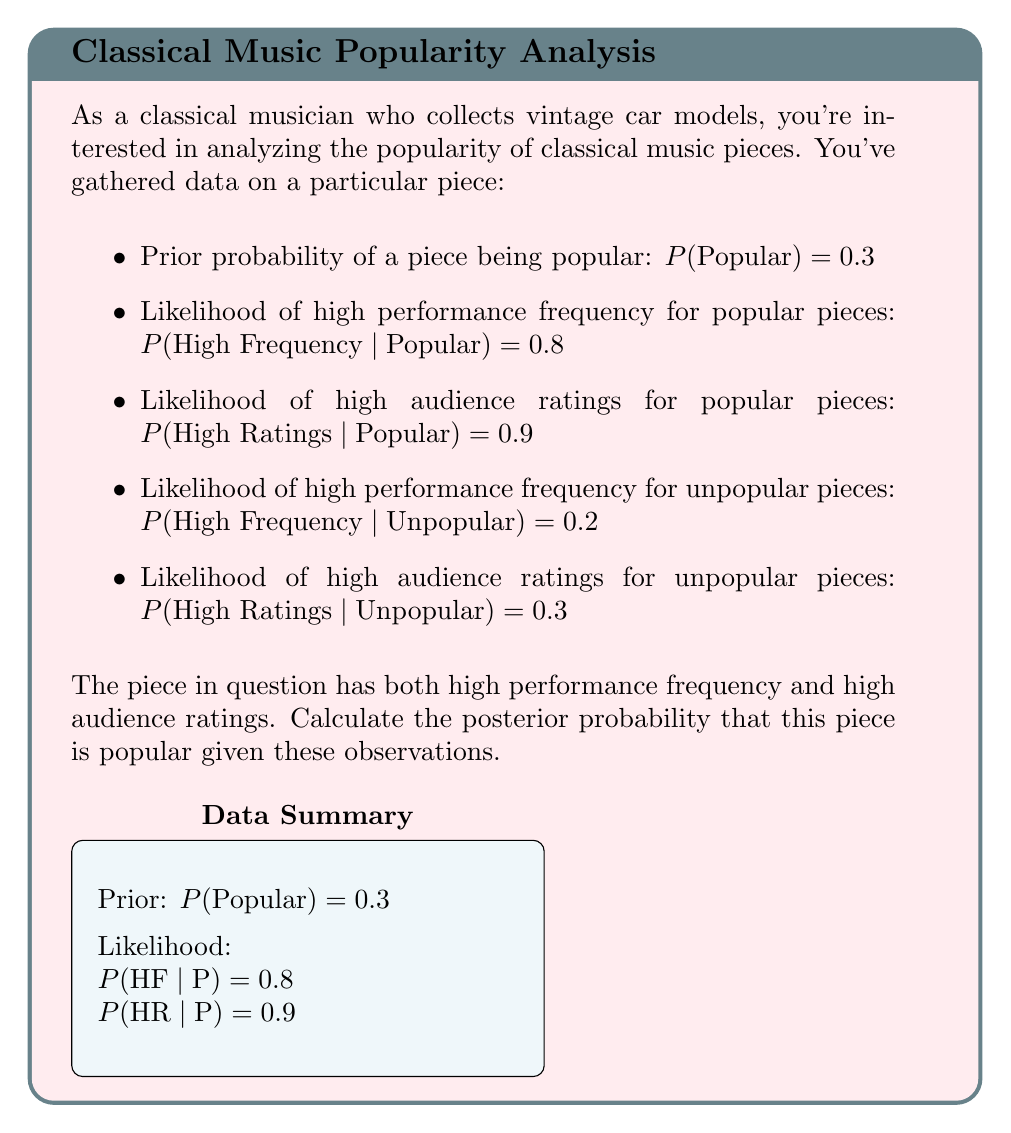Give your solution to this math problem. Let's solve this using Bayes' theorem:

1) Define events:
   P: The piece is popular
   HF: High Frequency
   HR: High Ratings

2) We want to find $P(P|HF,HR)$

3) Bayes' theorem:
   $$P(P|HF,HR) = \frac{P(HF,HR|P) \cdot P(P)}{P(HF,HR)}$$

4) Calculate $P(HF,HR|P)$:
   Assuming independence, $P(HF,HR|P) = P(HF|P) \cdot P(HR|P) = 0.8 \cdot 0.9 = 0.72$

5) Calculate $P(HF,HR)$ using the law of total probability:
   $$P(HF,HR) = P(HF,HR|P) \cdot P(P) + P(HF,HR|\text{not }P) \cdot P(\text{not }P)$$
   $$= 0.72 \cdot 0.3 + (0.2 \cdot 0.3) \cdot 0.7 = 0.216 + 0.042 = 0.258$$

6) Now we can apply Bayes' theorem:
   $$P(P|HF,HR) = \frac{0.72 \cdot 0.3}{0.258} = \frac{0.216}{0.258} \approx 0.8372$$

Therefore, the posterior probability that the piece is popular given high frequency and high ratings is approximately 0.8372 or 83.72%.
Answer: $0.8372$ (or $83.72\%$) 